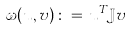Convert formula to latex. <formula><loc_0><loc_0><loc_500><loc_500>\omega ( u , v ) \, \colon = \, u ^ { T } \mathbb { J } v</formula> 